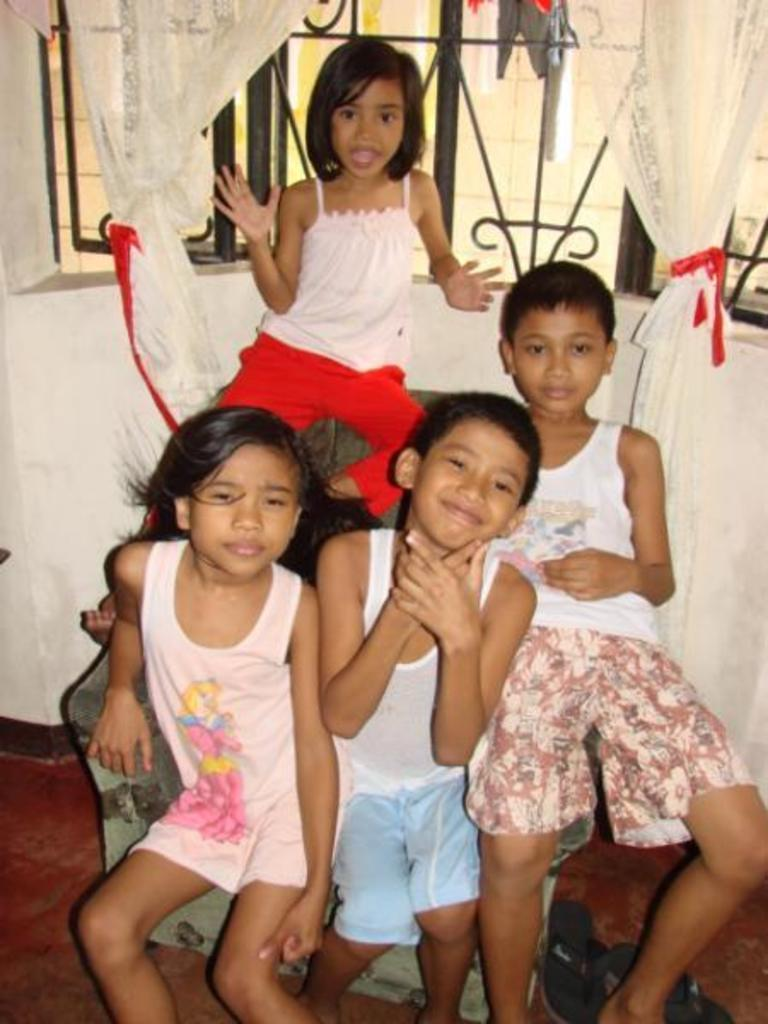What are the kids doing in the image? The kids are sitting on chairs in the image. What is behind the kids? There is a wall behind the kids. What feature is present on the wall? The wall has a window. How is the window covered? The window is covered with a curtain. What can be seen through the window? Clothes are visible through the window. What type of drain is visible in the image? There is no drain present in the image. What is the title of the image? The image does not have a title. 